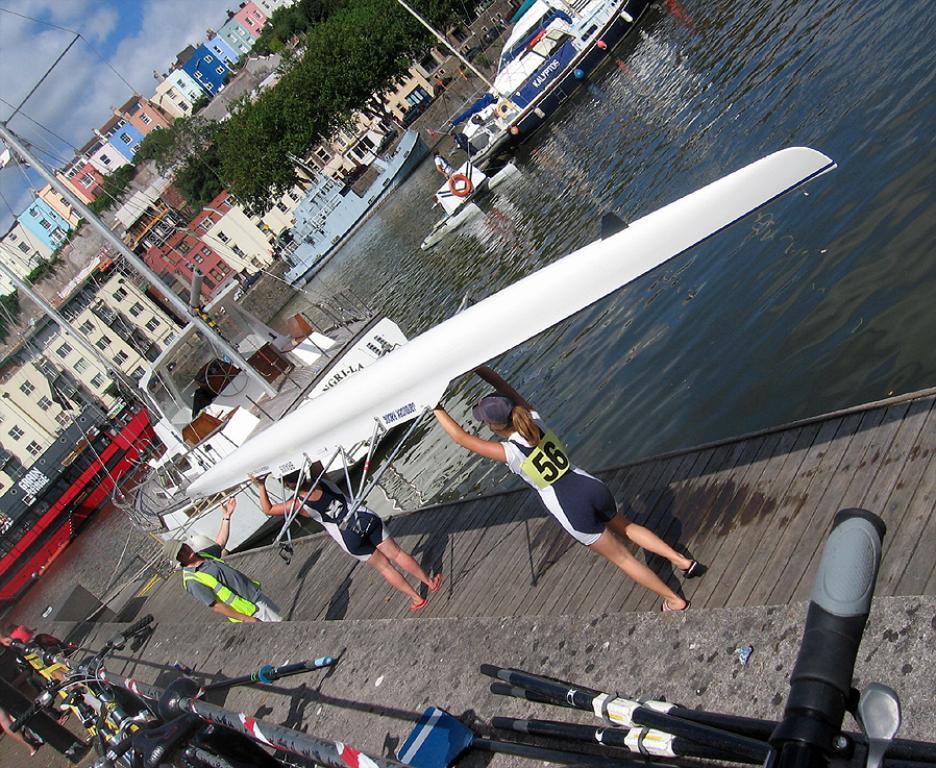What number is the player?
Provide a short and direct response. 56. 